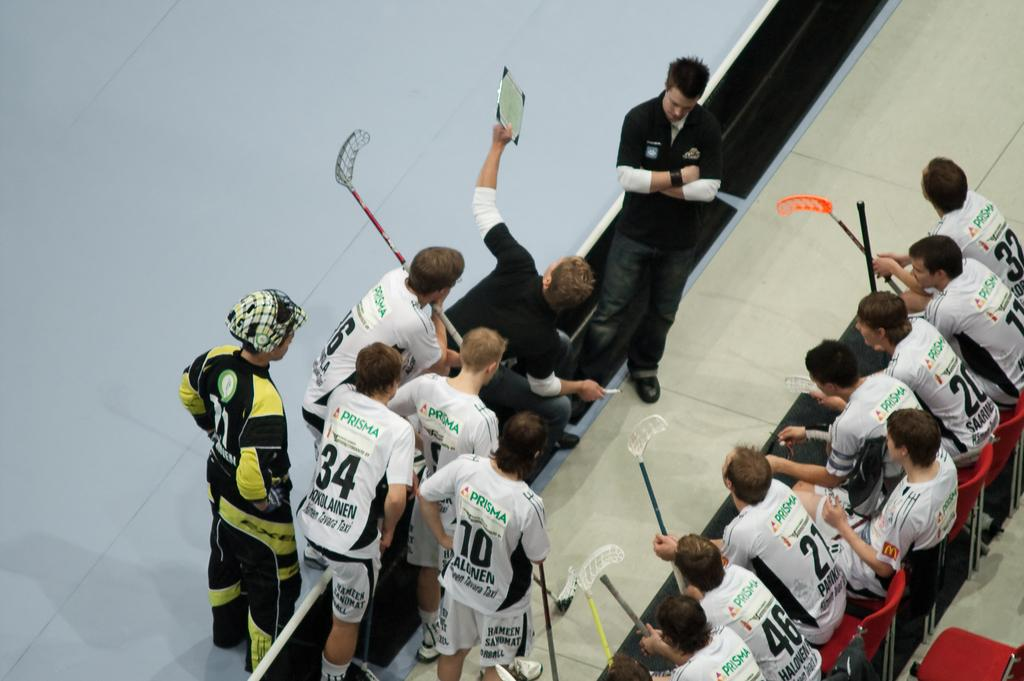What are the people in the image doing? The people in the image are sitting on chairs and standing. What are the people holding in their hands? The people are holding sticks in their hands. What is the name of the person sitting on the floor in the image? There is no person sitting on the floor in the image. 